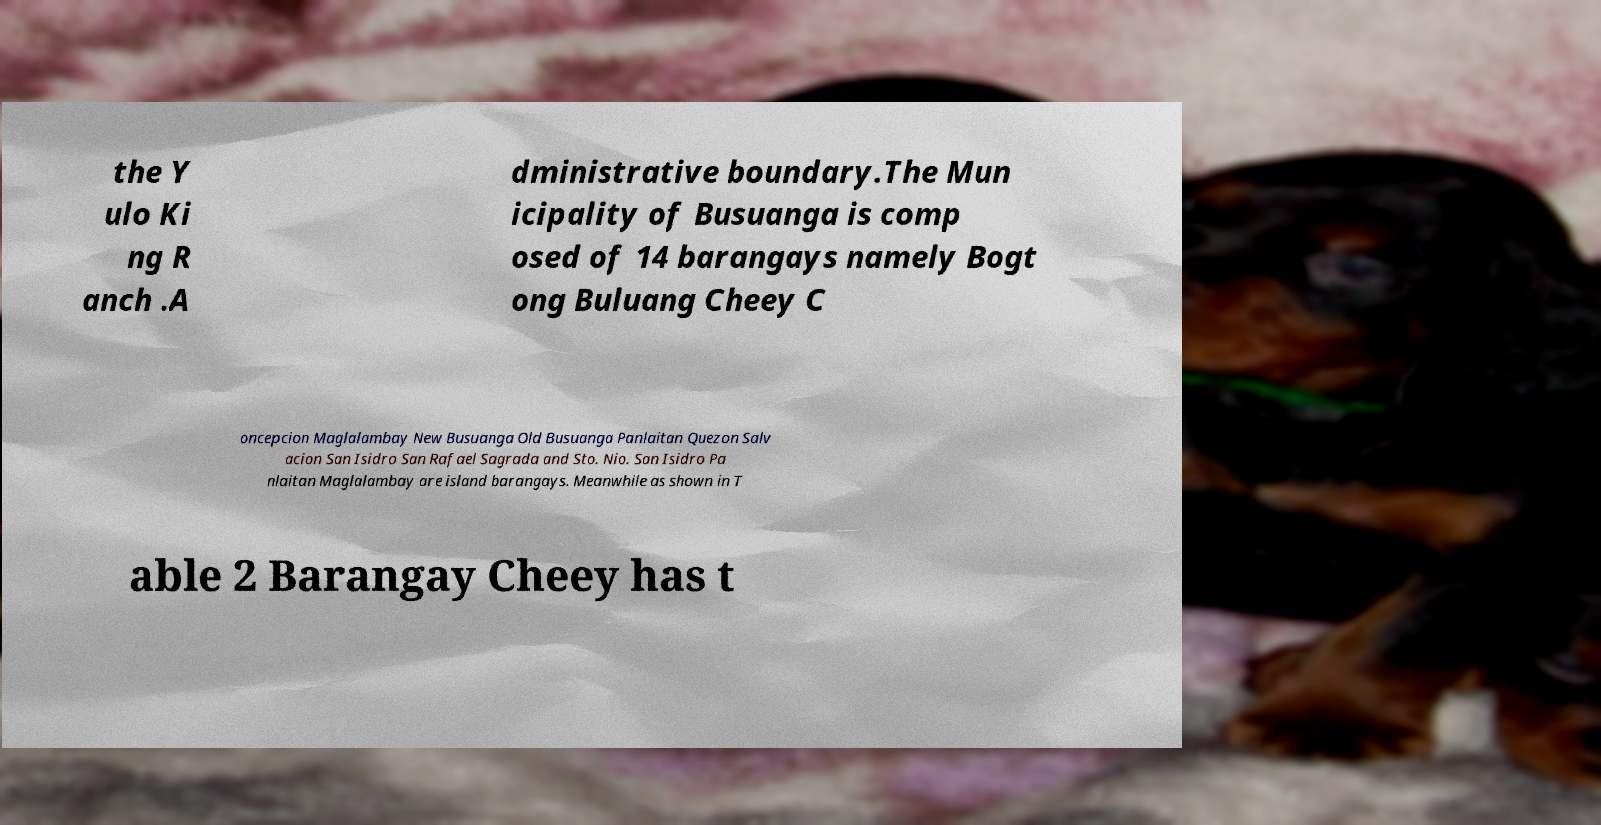There's text embedded in this image that I need extracted. Can you transcribe it verbatim? the Y ulo Ki ng R anch .A dministrative boundary.The Mun icipality of Busuanga is comp osed of 14 barangays namely Bogt ong Buluang Cheey C oncepcion Maglalambay New Busuanga Old Busuanga Panlaitan Quezon Salv acion San Isidro San Rafael Sagrada and Sto. Nio. San Isidro Pa nlaitan Maglalambay are island barangays. Meanwhile as shown in T able 2 Barangay Cheey has t 